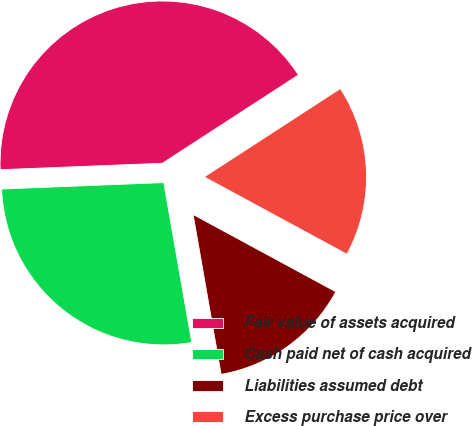Convert chart to OTSL. <chart><loc_0><loc_0><loc_500><loc_500><pie_chart><fcel>Fair value of assets acquired<fcel>Cash paid net of cash acquired<fcel>Liabilities assumed debt<fcel>Excess purchase price over<nl><fcel>41.47%<fcel>27.13%<fcel>14.34%<fcel>17.06%<nl></chart> 